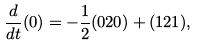Convert formula to latex. <formula><loc_0><loc_0><loc_500><loc_500>\frac { d } { d t } ( 0 ) = - \frac { 1 } { 2 } ( 0 2 0 ) + ( 1 2 1 ) ,</formula> 